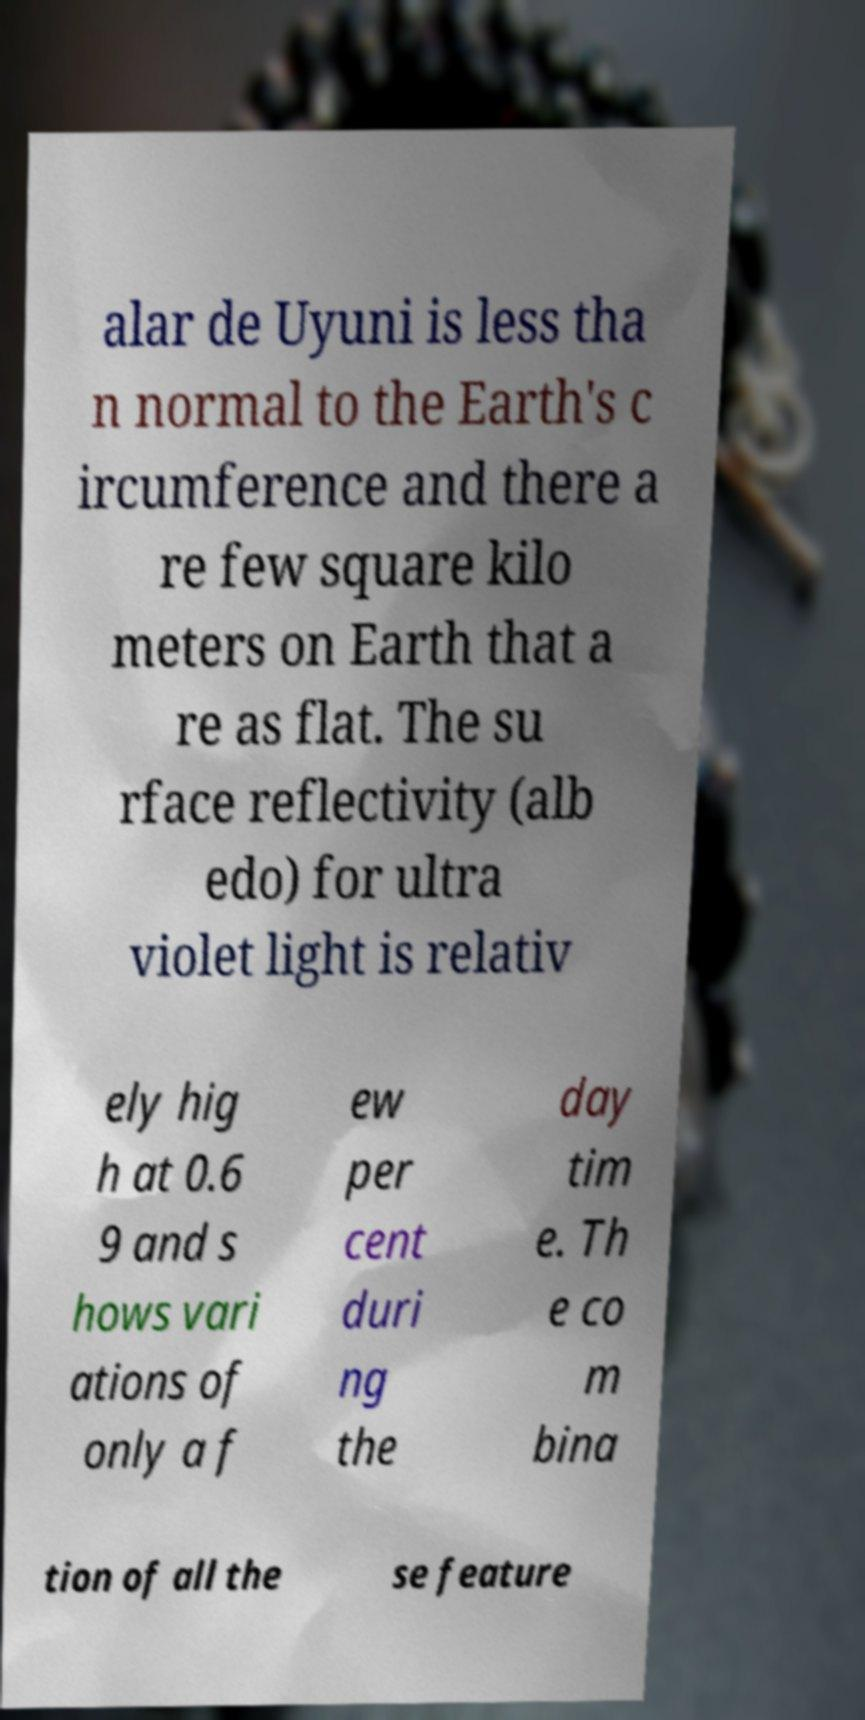Could you extract and type out the text from this image? alar de Uyuni is less tha n normal to the Earth's c ircumference and there a re few square kilo meters on Earth that a re as flat. The su rface reflectivity (alb edo) for ultra violet light is relativ ely hig h at 0.6 9 and s hows vari ations of only a f ew per cent duri ng the day tim e. Th e co m bina tion of all the se feature 